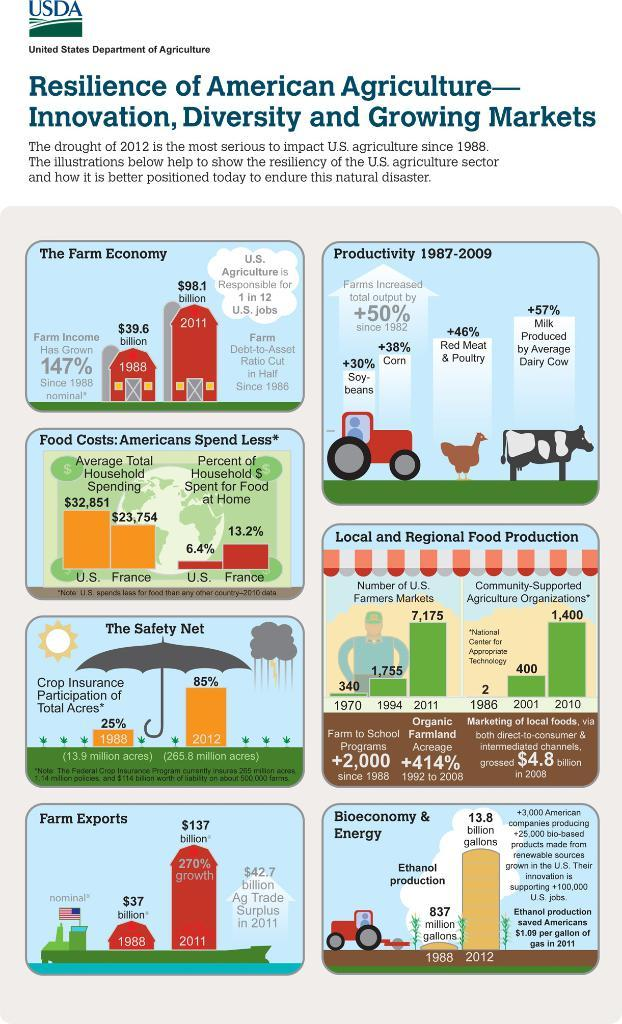What is the main subject of the image? The main subject of the image is a page. What can be seen at the top of the page? There is text at the top of the image. What type of objects are depicted in the image? There are images of an umbrella, a car, a cow, and a person in the image. Are there any numerical elements in the image? Yes, there are some numbers in the image. Can you tell me how many icicles are hanging from the car in the image? There are no icicles present in the image; it features an image of a car along with other objects. What type of gun is being used by the person in the image? There is no gun present in the image; it features an image of a person along with other objects. 